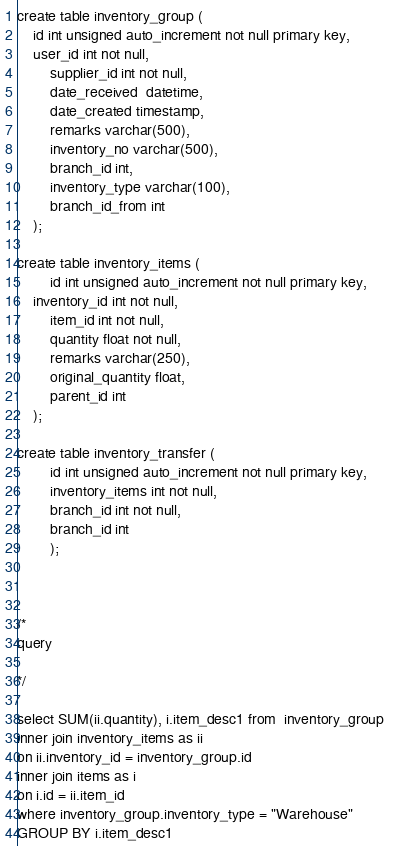Convert code to text. <code><loc_0><loc_0><loc_500><loc_500><_SQL_>create table inventory_group (
	id int unsigned auto_increment not null primary key,
	user_id int not null,
        supplier_id int not null,
        date_received  datetime, 
        date_created timestamp,
        remarks varchar(500),
        inventory_no varchar(500),
        branch_id int,
        inventory_type varchar(100),
        branch_id_from int
	);
    
create table inventory_items (
        id int unsigned auto_increment not null primary key,
	inventory_id int not null,
        item_id int not null,
        quantity float not null, 
        remarks varchar(250),
        original_quantity float,
        parent_id int
	);

create table inventory_transfer (
        id int unsigned auto_increment not null primary key,
        inventory_items int not null,
        branch_id int not null,
        branch_id int  
        );



/*
query

*/

select SUM(ii.quantity), i.item_desc1 from  inventory_group 
inner join inventory_items as ii
on ii.inventory_id = inventory_group.id
inner join items as i
on i.id = ii.item_id
where inventory_group.inventory_type = "Warehouse"
GROUP BY i.item_desc1
</code> 